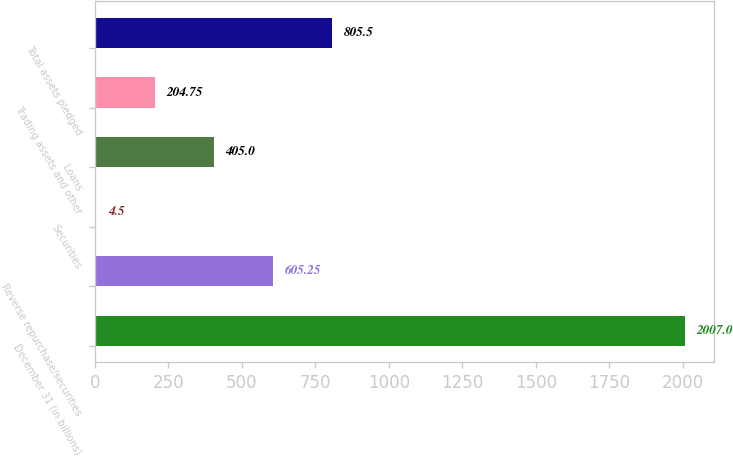Convert chart. <chart><loc_0><loc_0><loc_500><loc_500><bar_chart><fcel>December 31 (in billions)<fcel>Reverse repurchase/securities<fcel>Securities<fcel>Loans<fcel>Trading assets and other<fcel>Total assets pledged<nl><fcel>2007<fcel>605.25<fcel>4.5<fcel>405<fcel>204.75<fcel>805.5<nl></chart> 